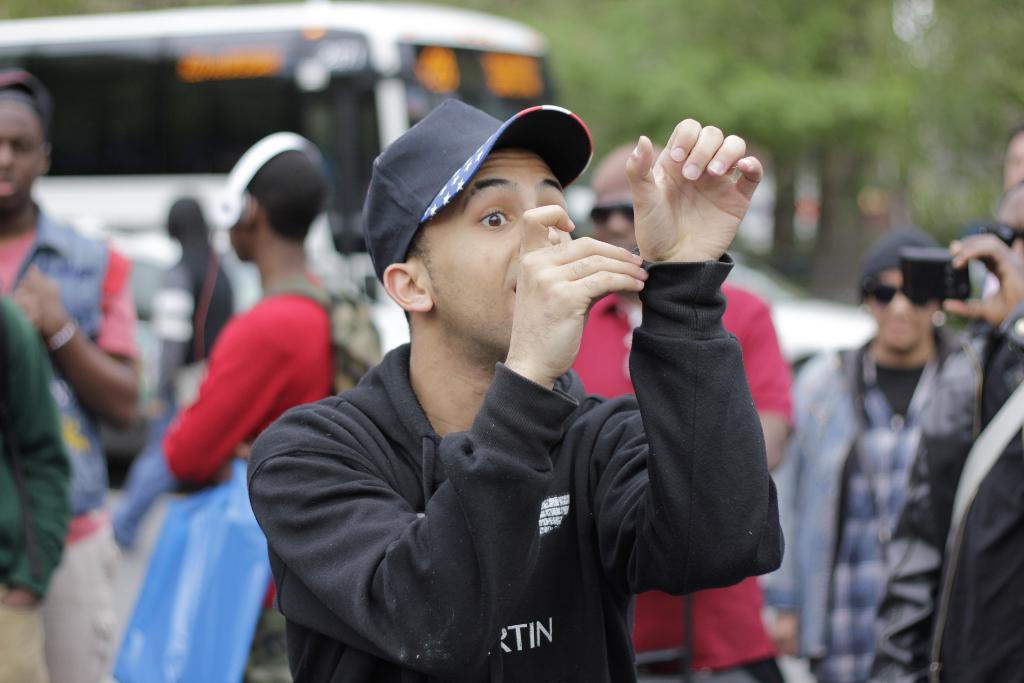Please provide a concise description of this image. In this picture we can see some people standing here, a man in the front wore a cap, a person on the right side is holding a mobile phone, in the background there are some trees and a bus here. 